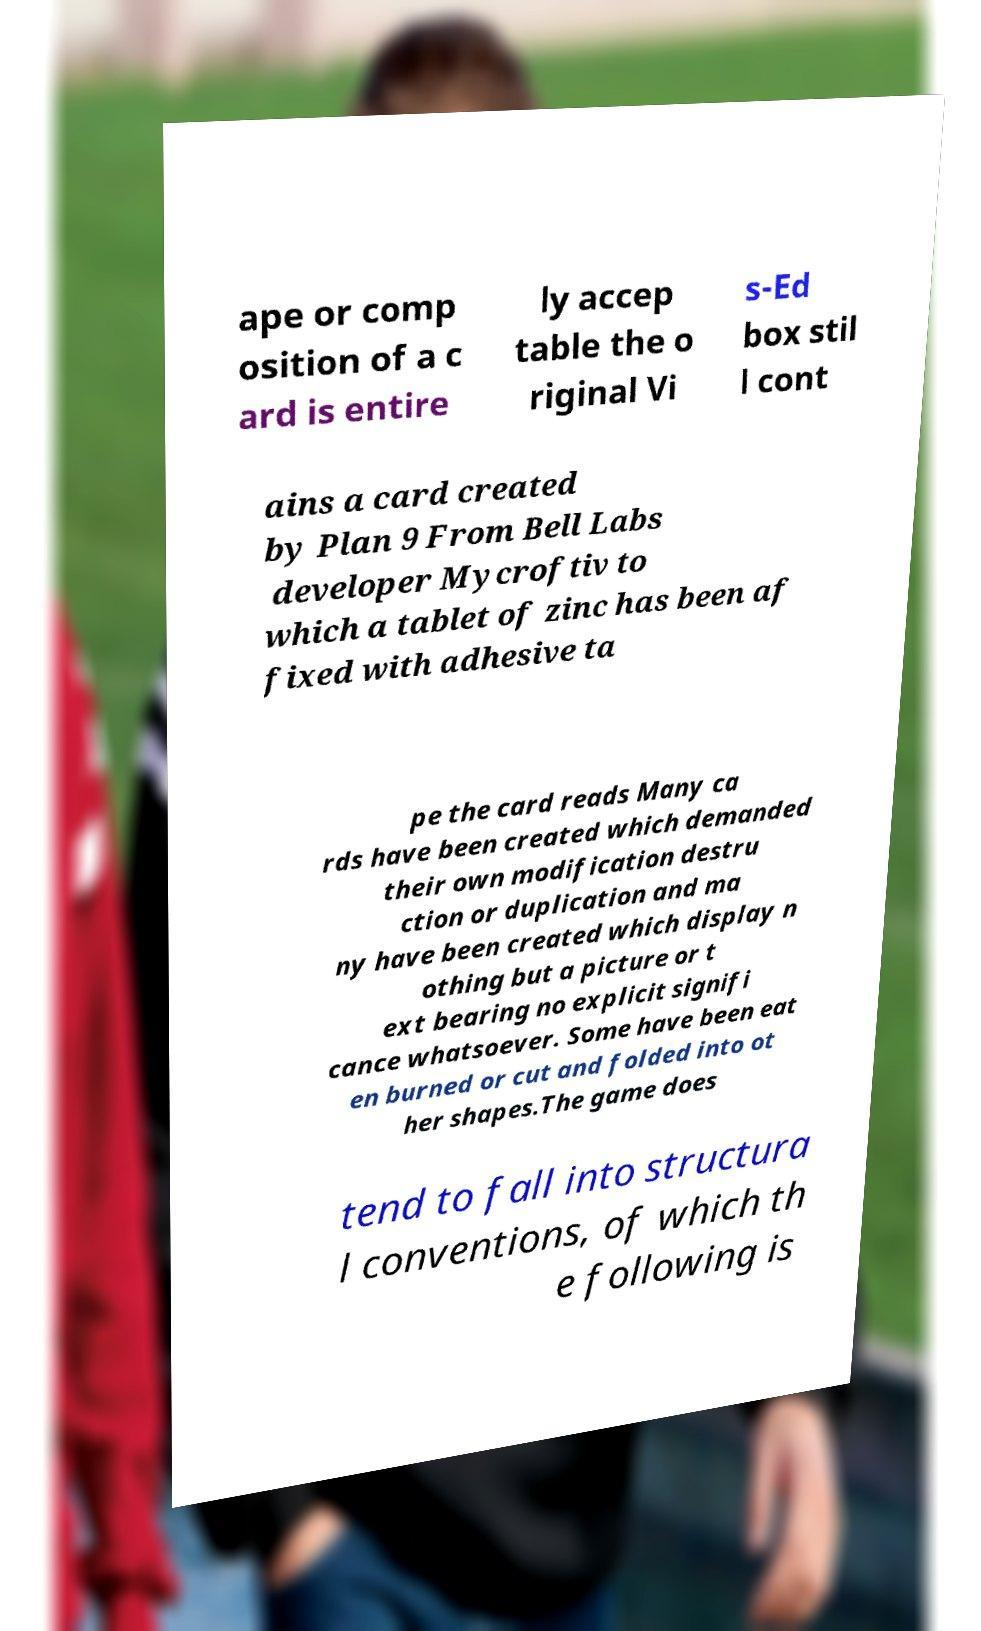Could you assist in decoding the text presented in this image and type it out clearly? ape or comp osition of a c ard is entire ly accep table the o riginal Vi s-Ed box stil l cont ains a card created by Plan 9 From Bell Labs developer Mycroftiv to which a tablet of zinc has been af fixed with adhesive ta pe the card reads Many ca rds have been created which demanded their own modification destru ction or duplication and ma ny have been created which display n othing but a picture or t ext bearing no explicit signifi cance whatsoever. Some have been eat en burned or cut and folded into ot her shapes.The game does tend to fall into structura l conventions, of which th e following is 